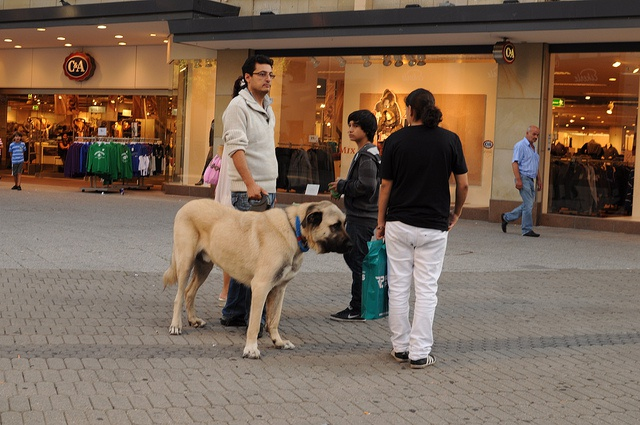Describe the objects in this image and their specific colors. I can see people in gray, black, darkgray, and lightgray tones, dog in gray, tan, and black tones, people in gray, darkgray, and black tones, people in gray, black, tan, and maroon tones, and people in gray, tan, darkgray, and lightgray tones in this image. 